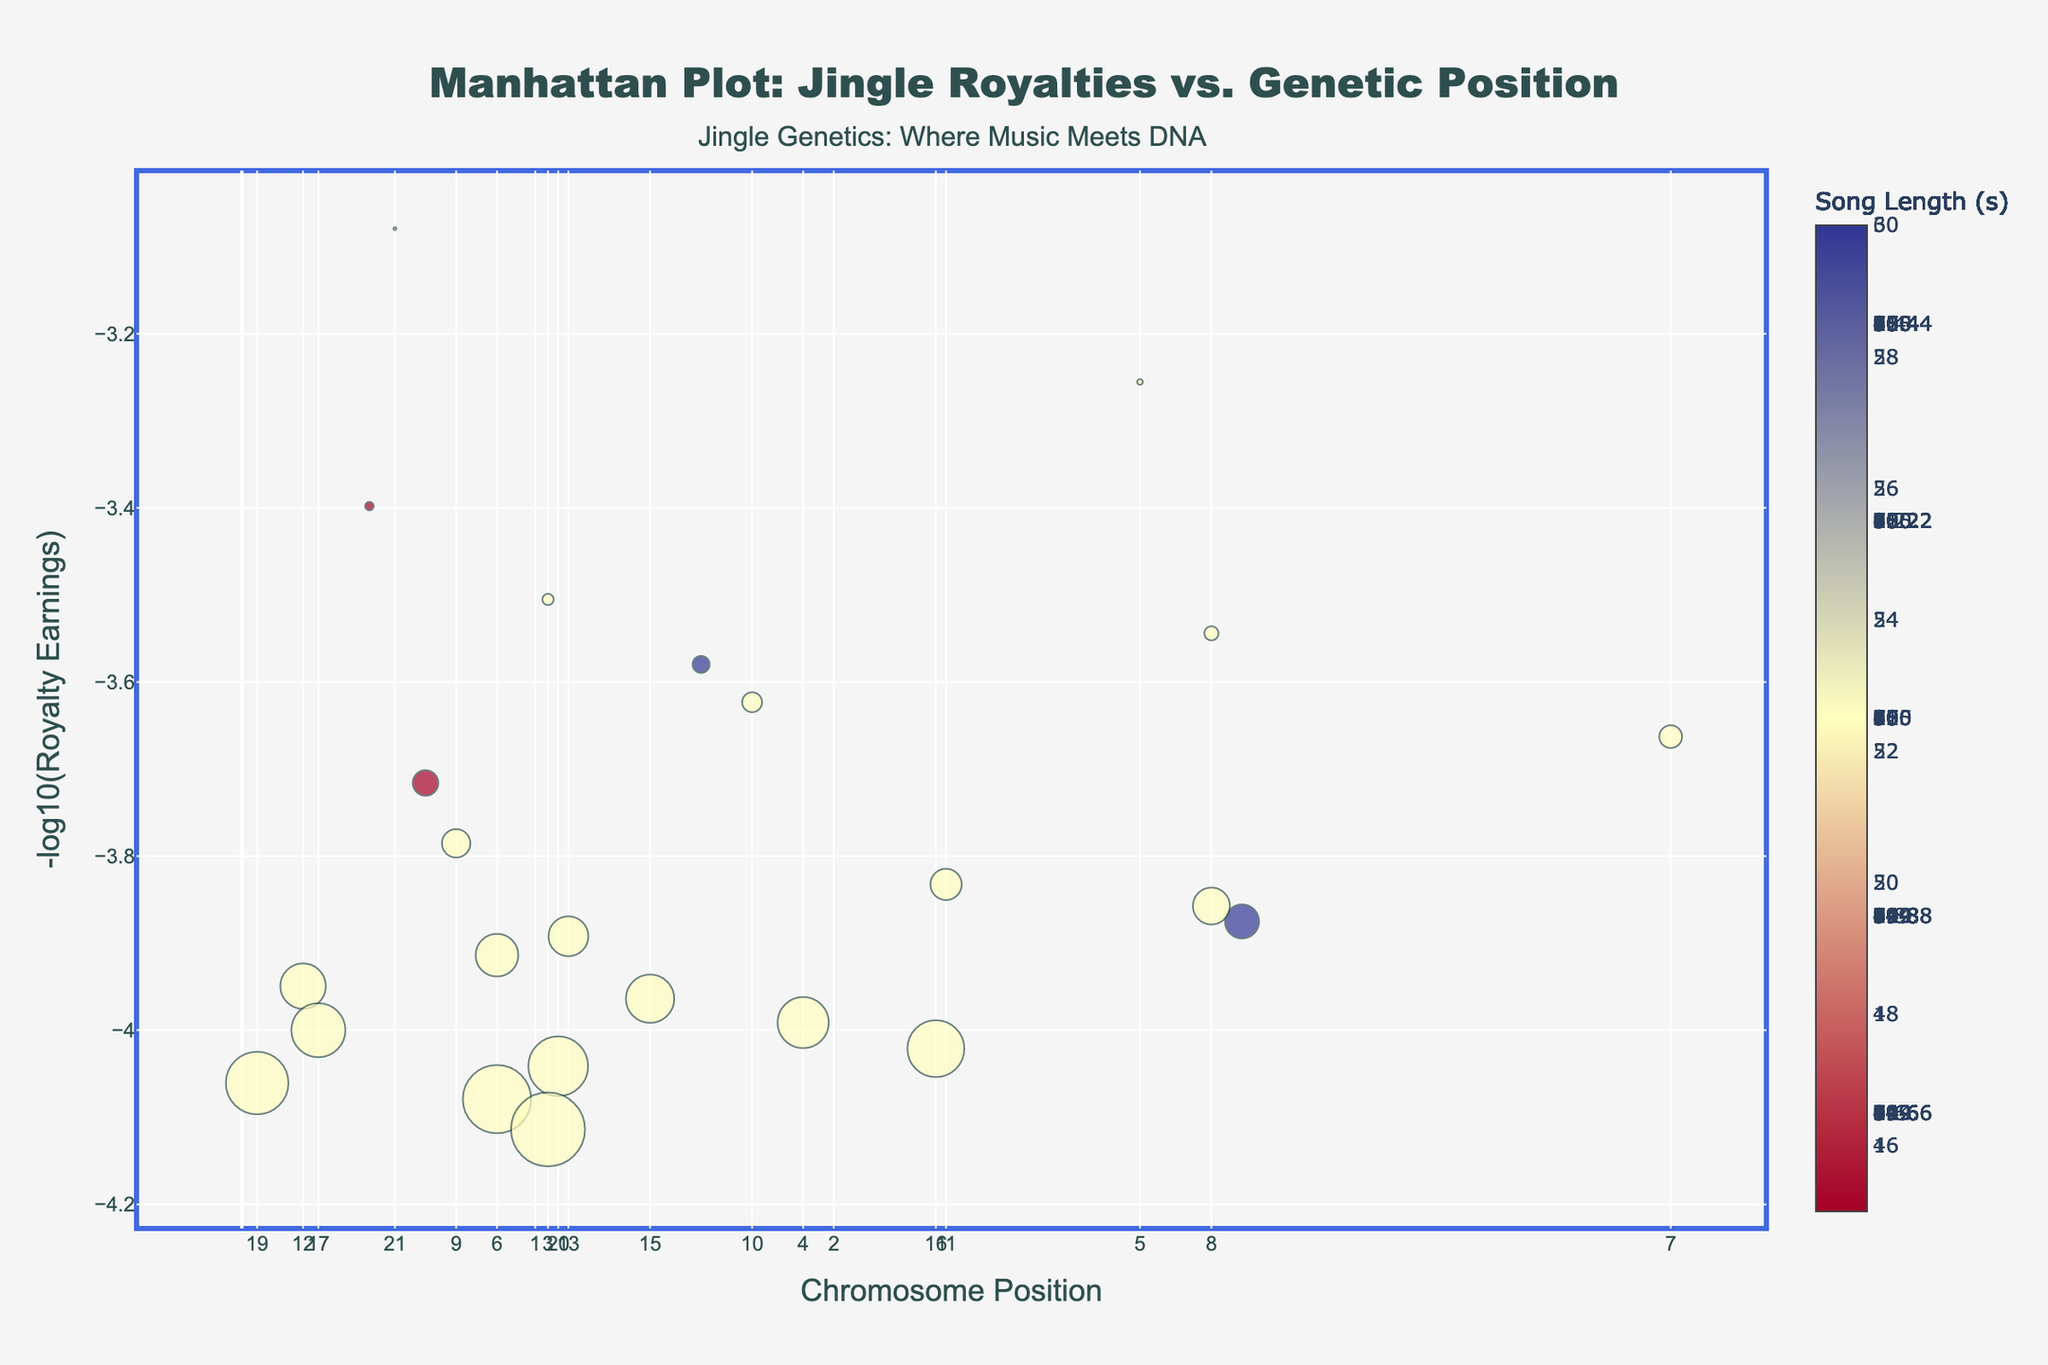What is the title of the plot? The title is usually found at the top of the plot and stands out due to its size and boldness. In this plot, it states "Manhattan Plot: Jingle Royalties vs. Genetic Position".
Answer: Manhattan Plot: Jingle Royalties vs. Genetic Position How is song length represented visually in the plot? Song length is often represented by either color, size, or specific markers. In this plot, it is represented by the size of the markers and color where larger and darker markers indicate longer songs.
Answer: By the size and color of the markers Which chromosome has the highest royalty earnings? In the plot, royalty earnings are represented on a -log10 scale on the y-axis, so the highest point on the y-axis signifies the highest earnings. Chromosome 22 has the highest point on the y-axis, indicating the highest royalty earnings.
Answer: Chromosome 22 What is the range of the song lengths depicted in the plot? The song length affects the size and color of the markers. Observing the plot carefully shows that song lengths vary between very small markers (5 seconds) and very large markers (130 seconds).
Answer: 5 to 130 seconds Which gene corresponds to the highest royalty earnings, and what is its position? The highest point on the y-axis has a label showing detailed data about the point. The highest point is annotated with "EWSR1" at position 30,000,000 on Chromosome 22.
Answer: EWSR1, position 30,000,000 How does the royalty earning for the gene MYC compare to the gene TP53? To compare the two points, locate their positions on the y-axis. For MYC on Chromosome 8, the -log10 of royalty is around 3.54; for TP53 on Chromosome 17, it is around 4.00. This indicates that TP53 has higher earnings than MYC.
Answer: TP53 has higher earnings than MYC What overall trend can be observed between song length and royalty earnings for the genes? Generally, larger markers indicating longer songs tend to appear higher on the y-axis, meaning there is a trend that longer songs correspond to higher royalty earnings.
Answer: Longer songs earn more royalties Which genes have similar royalty earnings in the range of 6.80 on the -log10 scale? By observing the y-axis and finding clusters or points around 6.80, CCND1 (on Chromosome 11) and CDKN2A (on Chromosome 9) fit in this range.
Answer: CCND1 and CDKN2A Which chromosome has the least visible variation in royalty earnings, and how can you tell? The chromosome with the least vertical spread or clustering of points shows the least variation. Chromosome 10 appears to have most points around a similar y-value, indicating low variation.
Answer: Chromosome 10 